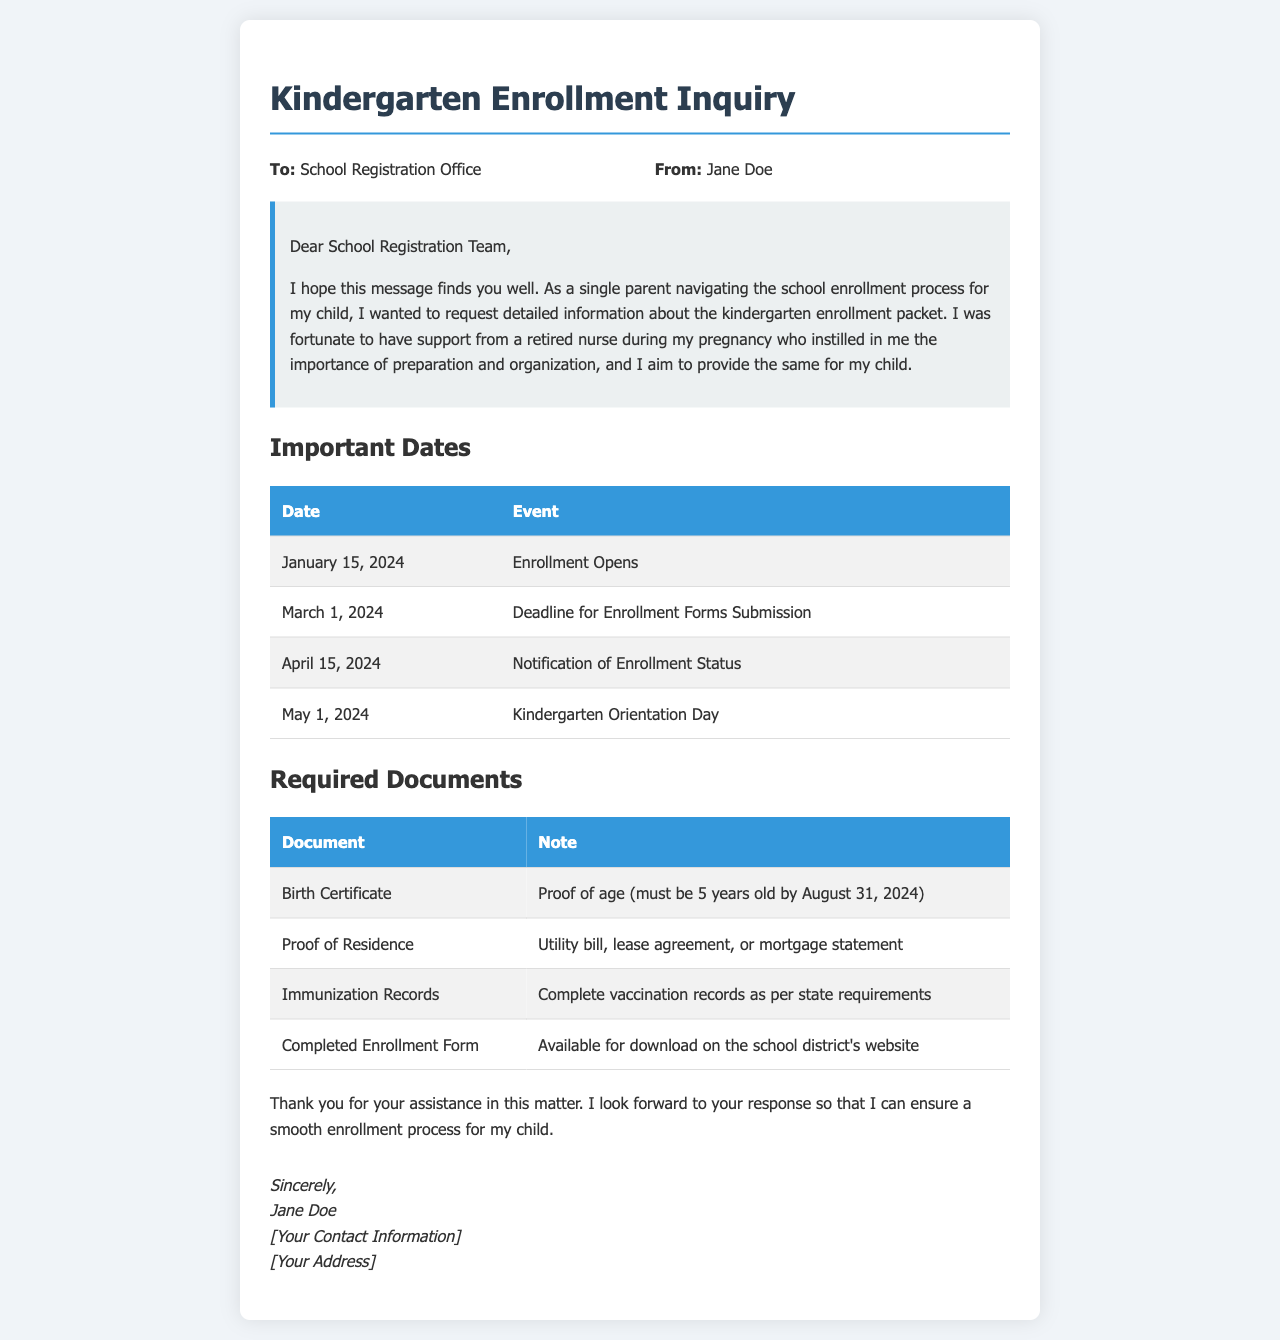What is the opening date for enrollment? The opening date for enrollment is stated in the document as January 15, 2024.
Answer: January 15, 2024 What document is needed to prove a child's age? The document needed to prove a child's age is the Birth Certificate, as mentioned in the required documents section.
Answer: Birth Certificate What is the deadline for enrollment forms submission? The deadline for enrollment forms submission is clearly indicated in the important dates section as March 1, 2024.
Answer: March 1, 2024 What is one of the required documents for enrollment? One of the required documents for enrollment is the Immunization Records, listed under the required documents.
Answer: Immunization Records What event occurs on May 1, 2024? The event on May 1, 2024, is the Kindergarten Orientation Day, as outlined in the important dates table.
Answer: Kindergarten Orientation Day Why is the retired nurse mentioned in the email? The retired nurse is mentioned to highlight the support and importance of preparation and organization during the school enrollment process.
Answer: Support and preparation How is the document structured? The document structure includes sections on important dates and required documents, along with a message from the sender.
Answer: Sections on important dates and required documents What color is used for the header of the document? The header color for the document is a shade of blue, consistent throughout the styled elements.
Answer: Blue 